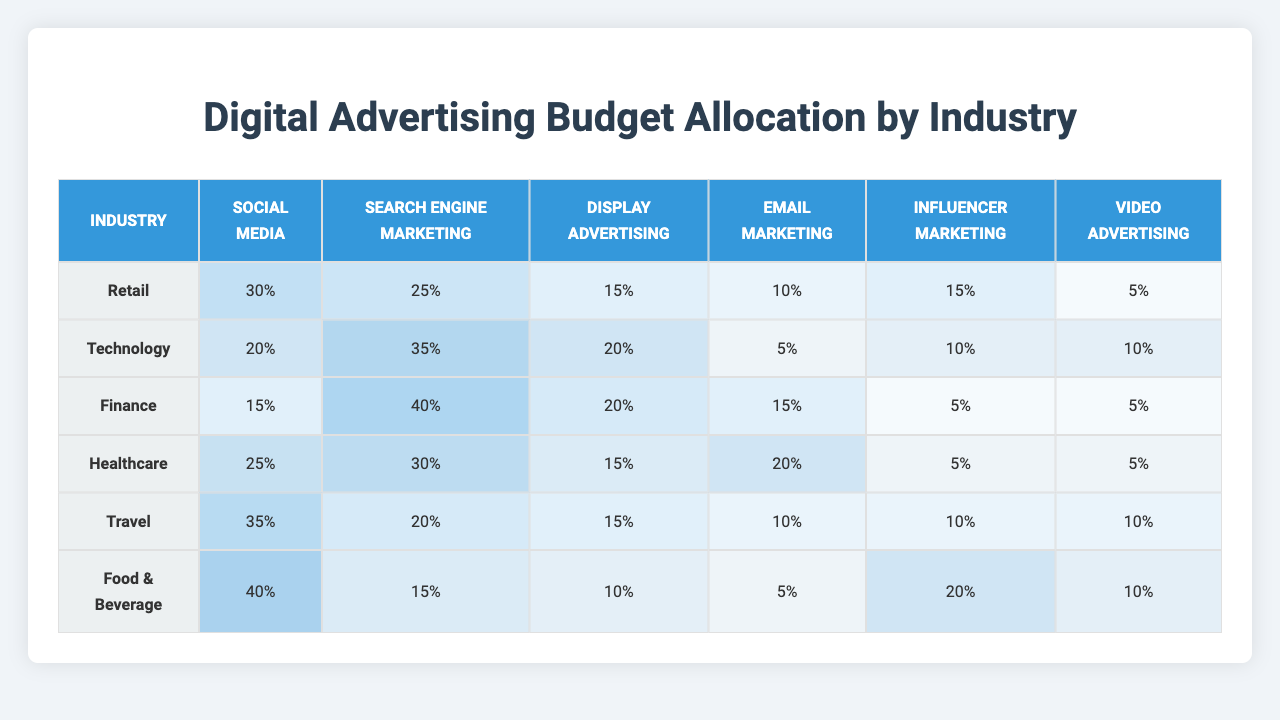What is the budget allocation for Social Media in the Technology sector? The Technology sector shows a budget allocation of 20% for Social Media, as indicated in the respective row of the table.
Answer: 20% Which industry allocates the highest percentage to Influencer Marketing? According to the table, the Food & Beverage industry allocates the highest percentage, which is 20%, for Influencer Marketing compared to other industries.
Answer: Food & Beverage What is the total budget allocation for Search Engine Marketing across all industries? Adding the values for Search Engine Marketing from each industry: 25 (Retail) + 35 (Technology) + 40 (Finance) + 30 (Healthcare) + 20 (Travel) + 15 (Food & Beverage) gives a total of 165%.
Answer: 165% Does the Healthcare industry allocate more to Email Marketing than the Travel industry? The Healthcare industry allocates 20% to Email Marketing while the Travel industry allocates 10%. Therefore, the Healthcare industry does allocate more to Email Marketing.
Answer: Yes Which industry has the lowest allocation for Video Advertising? The industries were checked for their Video Advertising allocation values: Retail (5%), Technology (10%), Finance (5%), Healthcare (5%), Travel (10%), and Food & Beverage (10%). The lowest allocation for Video Advertising is found in the Retail, Finance, and Healthcare sectors.
Answer: Retail, Finance, Healthcare What is the average budget allocation for Display Advertising across all industries? The Display Advertising percentages are 15, 20, 20, 15, 15, and 10. Summing these gives 95, and dividing by 6 industries results in an average of 15.83%.
Answer: 15.83% Which digital channel has the most varied budget allocation across all industries? To determine variation, a comparison of ranges is needed. Social Media (30% to 40%), Search Engine Marketing (15% to 40%), and Influencer Marketing (5% to 20%) show varying allocations. Search Engine Marketing shows the greatest range of 25%.
Answer: Search Engine Marketing Is there any industry that allocates 5% to both Email Marketing and Video Advertising? Examining the table, the Finance and Healthcare industries both allocate 5% to Video Advertising, but only that sums up to 5% for Email Marketing in the Finance sector.
Answer: Yes, Finance and Healthcare 